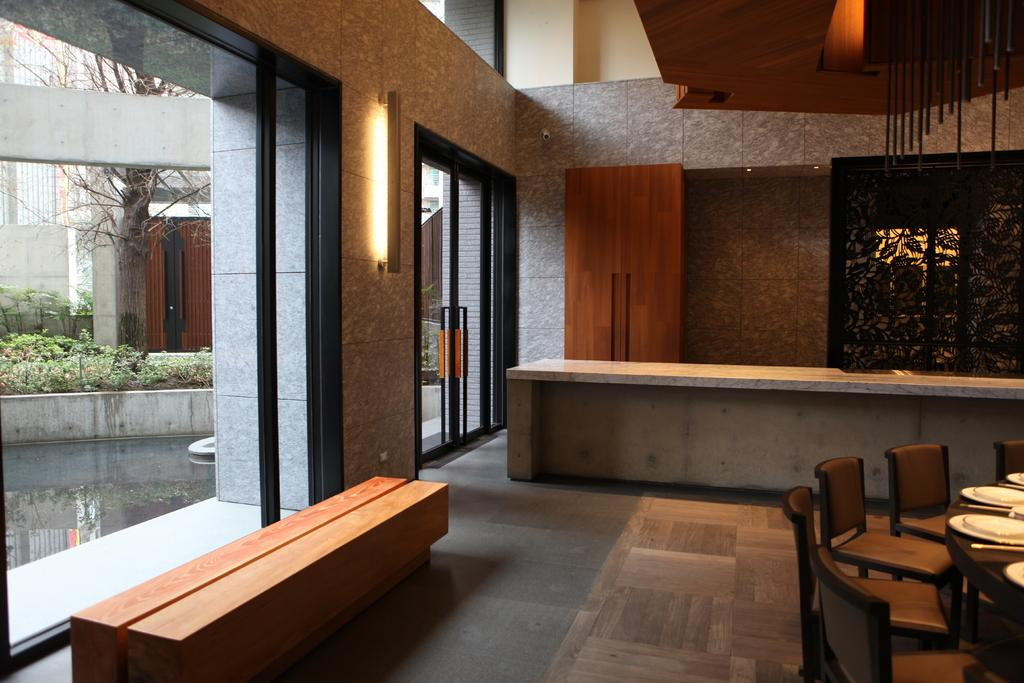What type of furniture is present in the image? There are chairs in the image. What is on the table in the image? There are plates on a table in the image. Can you describe a feature of the room in the image? There is a door in the image. What is depicted on the left side of the image? There are planets and a tree depicted on the left side of the image. Is there a brick wall visible in the image? There is no mention of a brick wall in the provided facts, so it cannot be confirmed or denied. Can you tell me how many credit cards are on the table in the image? There is no mention of credit cards in the provided facts, so it cannot be confirmed or denied. 